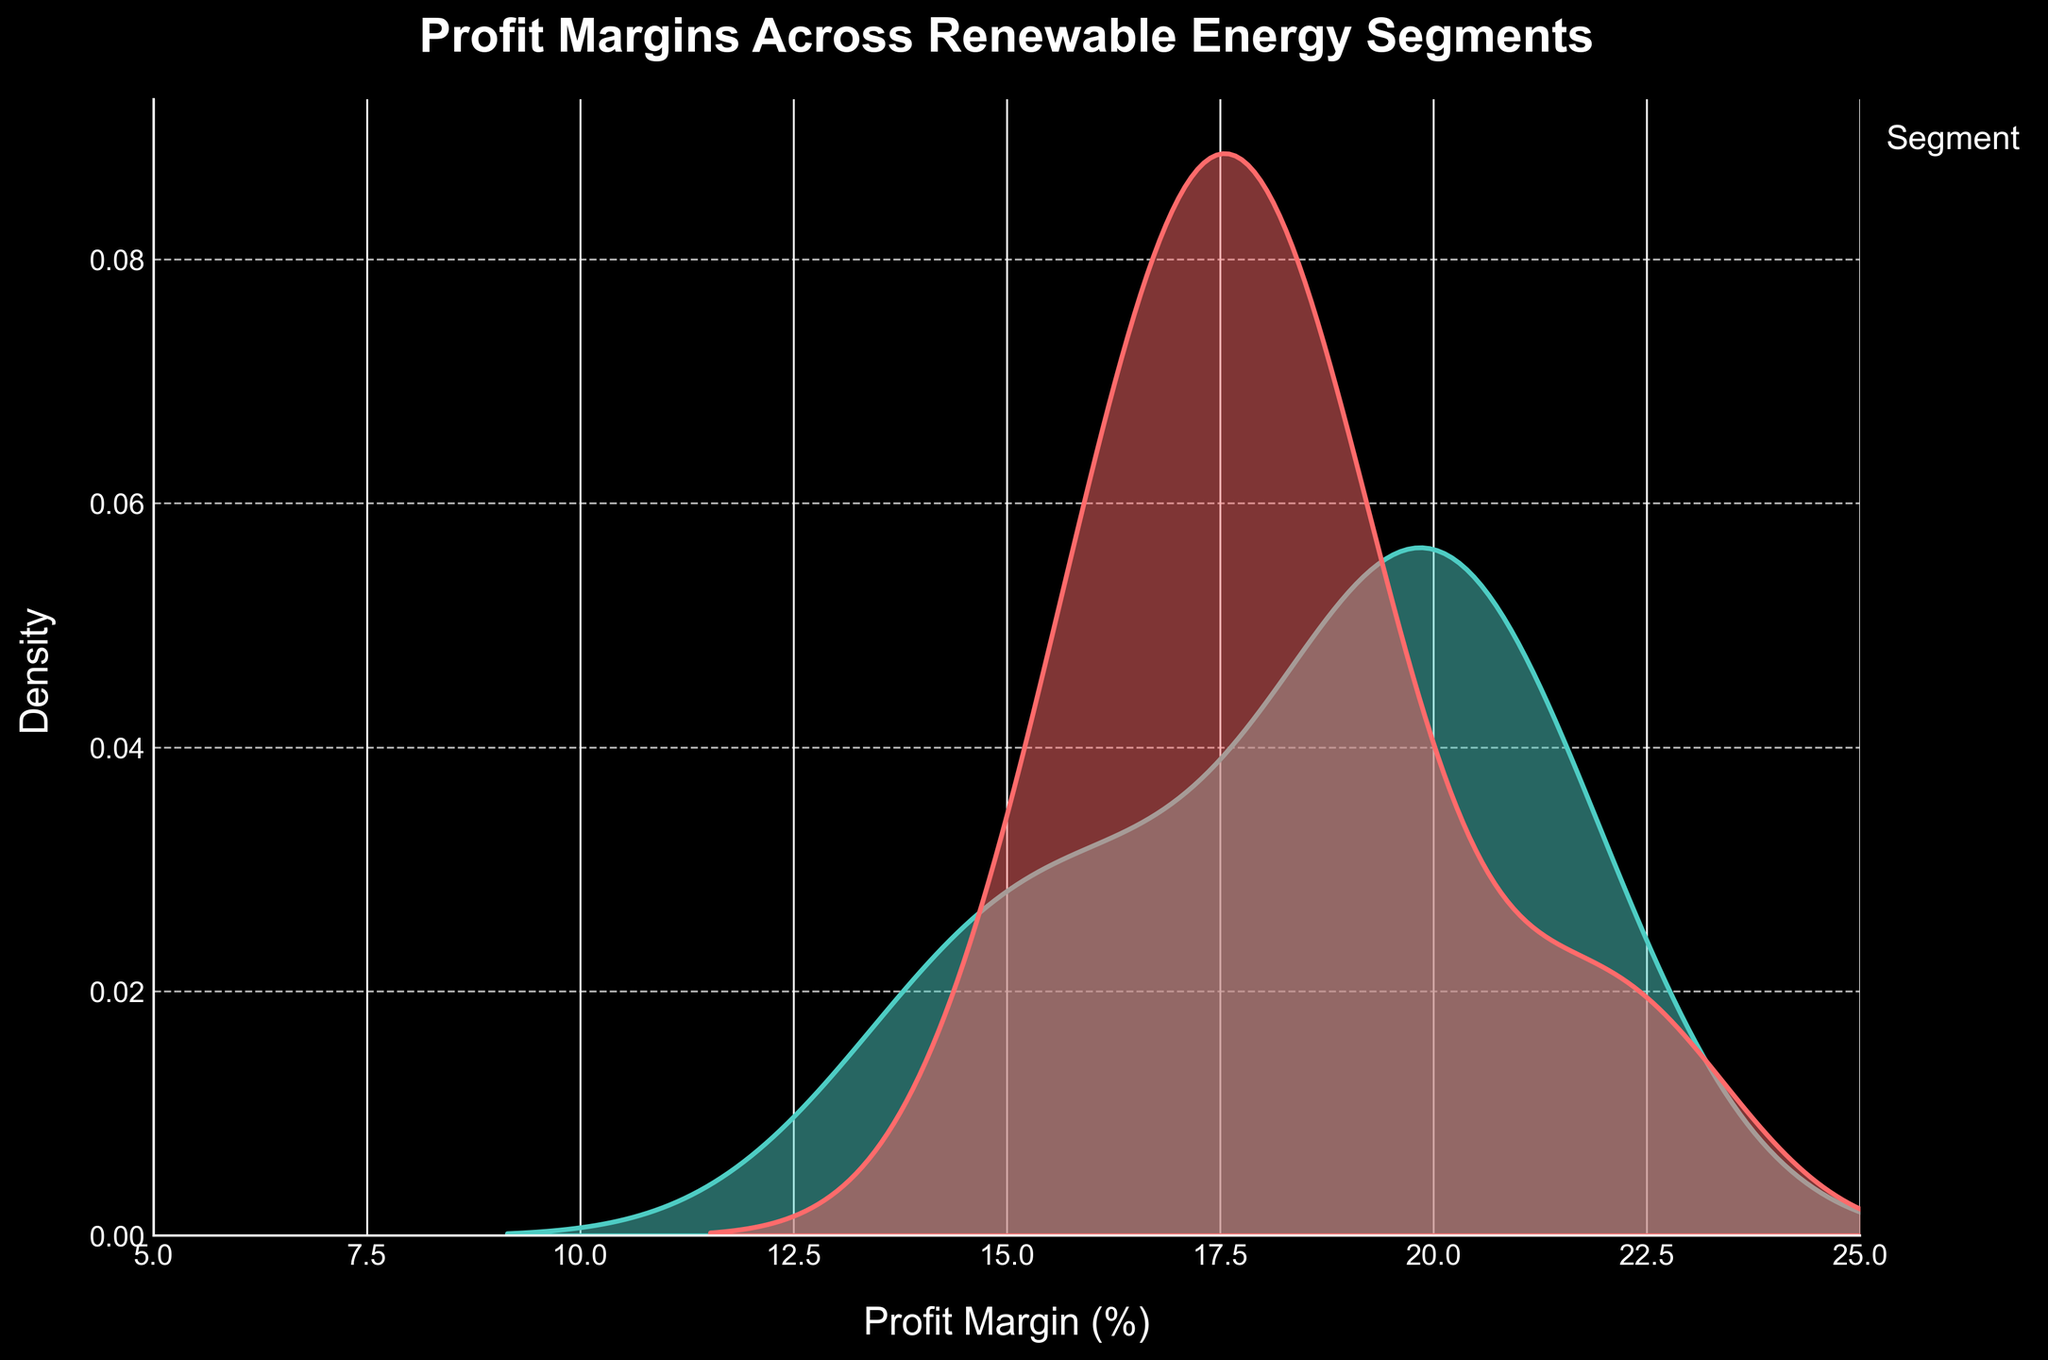Which segment has the highest peak density? The peak density for each segment is represented by the highest point in their respective curves. The Solar segment has the highest peak density in the plot.
Answer: Solar Which segment shows the widest spread in profit margins? By observing the width of each segment's curve, the Wind segment shows the widest spread, indicating a more diverse range of profit margins.
Answer: Wind What is the title of the plot? The title is written at the top of the plot. It reads "Profit Margins Across Renewable Energy Segments".
Answer: Profit Margins Across Renewable Energy Segments How many segments are displayed in the plot? The legend on the right side of the plot lists the segments shown. There are three distinct segments indicated.
Answer: Three Which segment has the narrowest spread in profit margins? By observing the width of each segment's curve, the Solar segment has the narrowest spread in profit margins, indicating a more consistent range.
Answer: Solar What is the range of the x-axis in this plot? The x-axis ranges from 5 to 25, as indicated by the axis labels.
Answer: 5 to 25 Which segment has profit margins greater than 20%? By examining the part of the plot where profit margins are above 20%, the Wind and Solar segments occasionally extend into this region.
Answer: Wind and Solar Is there a segment with a profit margin around 10%? Checking the left side of the plot around the 10% mark, the Biomass segment has a density peak close to this value.
Answer: Biomass Which segment appears to have multiple peaks in its distribution? The Biomass segment exhibits two peaks in its distribution, indicating multimodality.
Answer: Biomass Which segment has the highest density at a profit margin of 15%? Observing the plot at the 15% mark, the Solar segment shows the highest density at this specific profit margin.
Answer: Solar 